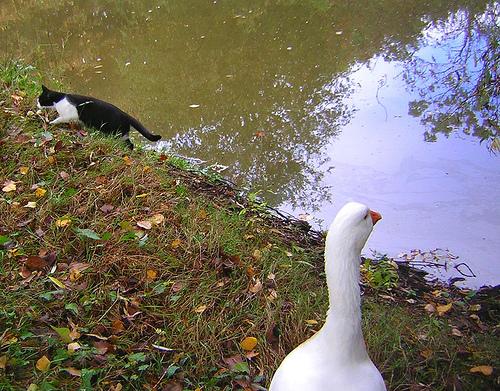Which of these animals is more at home in the water?
Concise answer only. Goose. Why are there so many together?
Be succinct. Trying to swim. What animal is closest to the water?
Answer briefly. Cat. Which is facing the water?
Keep it brief. Goose. 